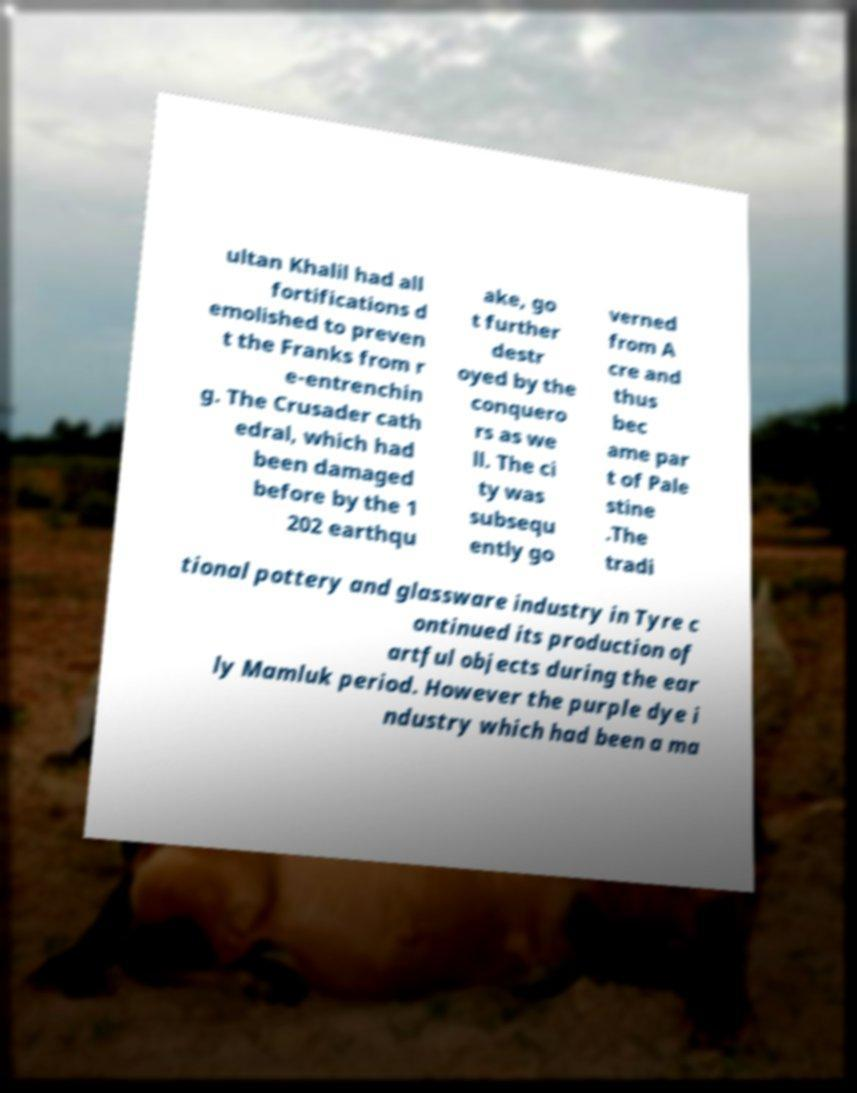Can you read and provide the text displayed in the image?This photo seems to have some interesting text. Can you extract and type it out for me? ultan Khalil had all fortifications d emolished to preven t the Franks from r e-entrenchin g. The Crusader cath edral, which had been damaged before by the 1 202 earthqu ake, go t further destr oyed by the conquero rs as we ll. The ci ty was subsequ ently go verned from A cre and thus bec ame par t of Pale stine .The tradi tional pottery and glassware industry in Tyre c ontinued its production of artful objects during the ear ly Mamluk period. However the purple dye i ndustry which had been a ma 